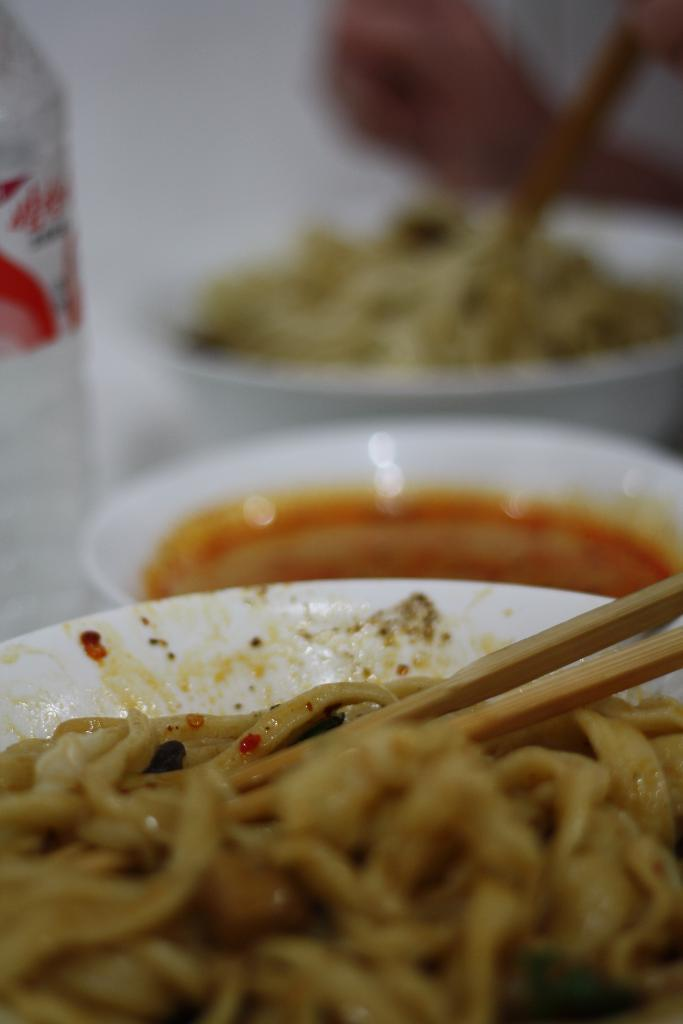What type of food can be seen in the image? There is food in the image, specifically soup. What utensil is used to eat the food in the image? Chopsticks are visible in the image. Can you describe the food in more detail? The food in the image is soup. What channel is the zebra watching in the image? There is no zebra or television present in the image. How does the soup blow in the image? The soup does not blow in the image; it is stationary in the bowl. 